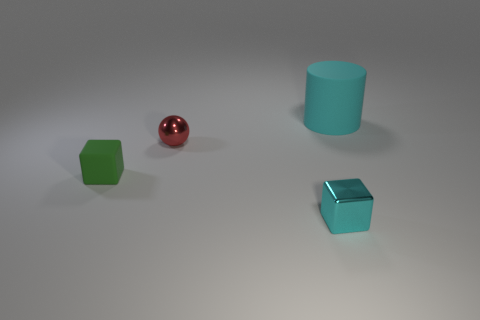There is a cube in front of the tiny green rubber block; are there any tiny rubber blocks in front of it?
Your response must be concise. No. What number of balls are either cyan things or tiny green matte things?
Offer a very short reply. 0. Are there any other large rubber things of the same shape as the green matte object?
Make the answer very short. No. What is the shape of the cyan metallic object?
Offer a very short reply. Cube. How many objects are either big purple matte cylinders or matte things?
Keep it short and to the point. 2. Do the object that is on the right side of the small cyan shiny object and the matte object to the left of the large cylinder have the same size?
Provide a short and direct response. No. How many other objects are there of the same material as the tiny red ball?
Your answer should be compact. 1. Is the number of small shiny balls that are on the left side of the tiny green matte cube greater than the number of small balls that are in front of the small ball?
Your answer should be compact. No. There is a thing that is on the left side of the red metal ball; what is its material?
Your response must be concise. Rubber. Is the shape of the tiny green thing the same as the red thing?
Your answer should be very brief. No. 